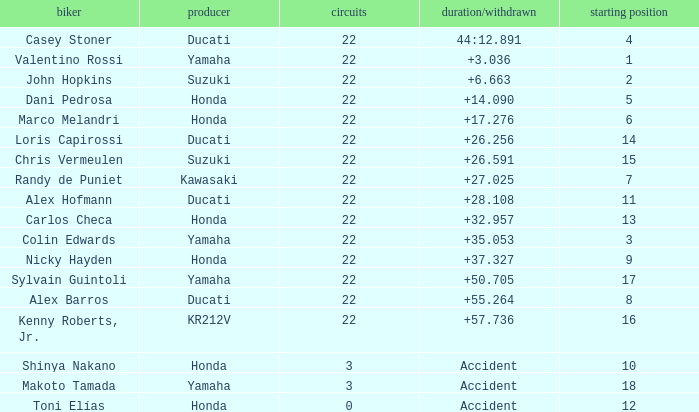What is the average grid for competitors who had more than 22 laps and time/retired of +17.276? None. 